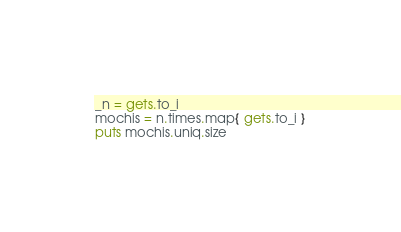<code> <loc_0><loc_0><loc_500><loc_500><_Ruby_>_n = gets.to_i
mochis = n.times.map{ gets.to_i }
puts mochis.uniq.size</code> 